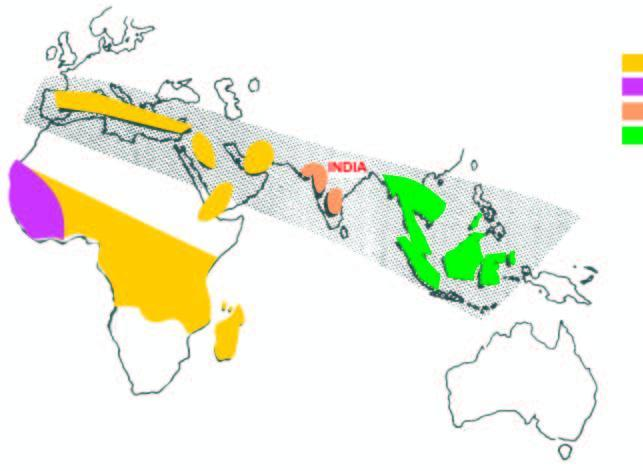what are common in india?
Answer the question using a single word or phrase. Thalassaemia and hbd disorders 